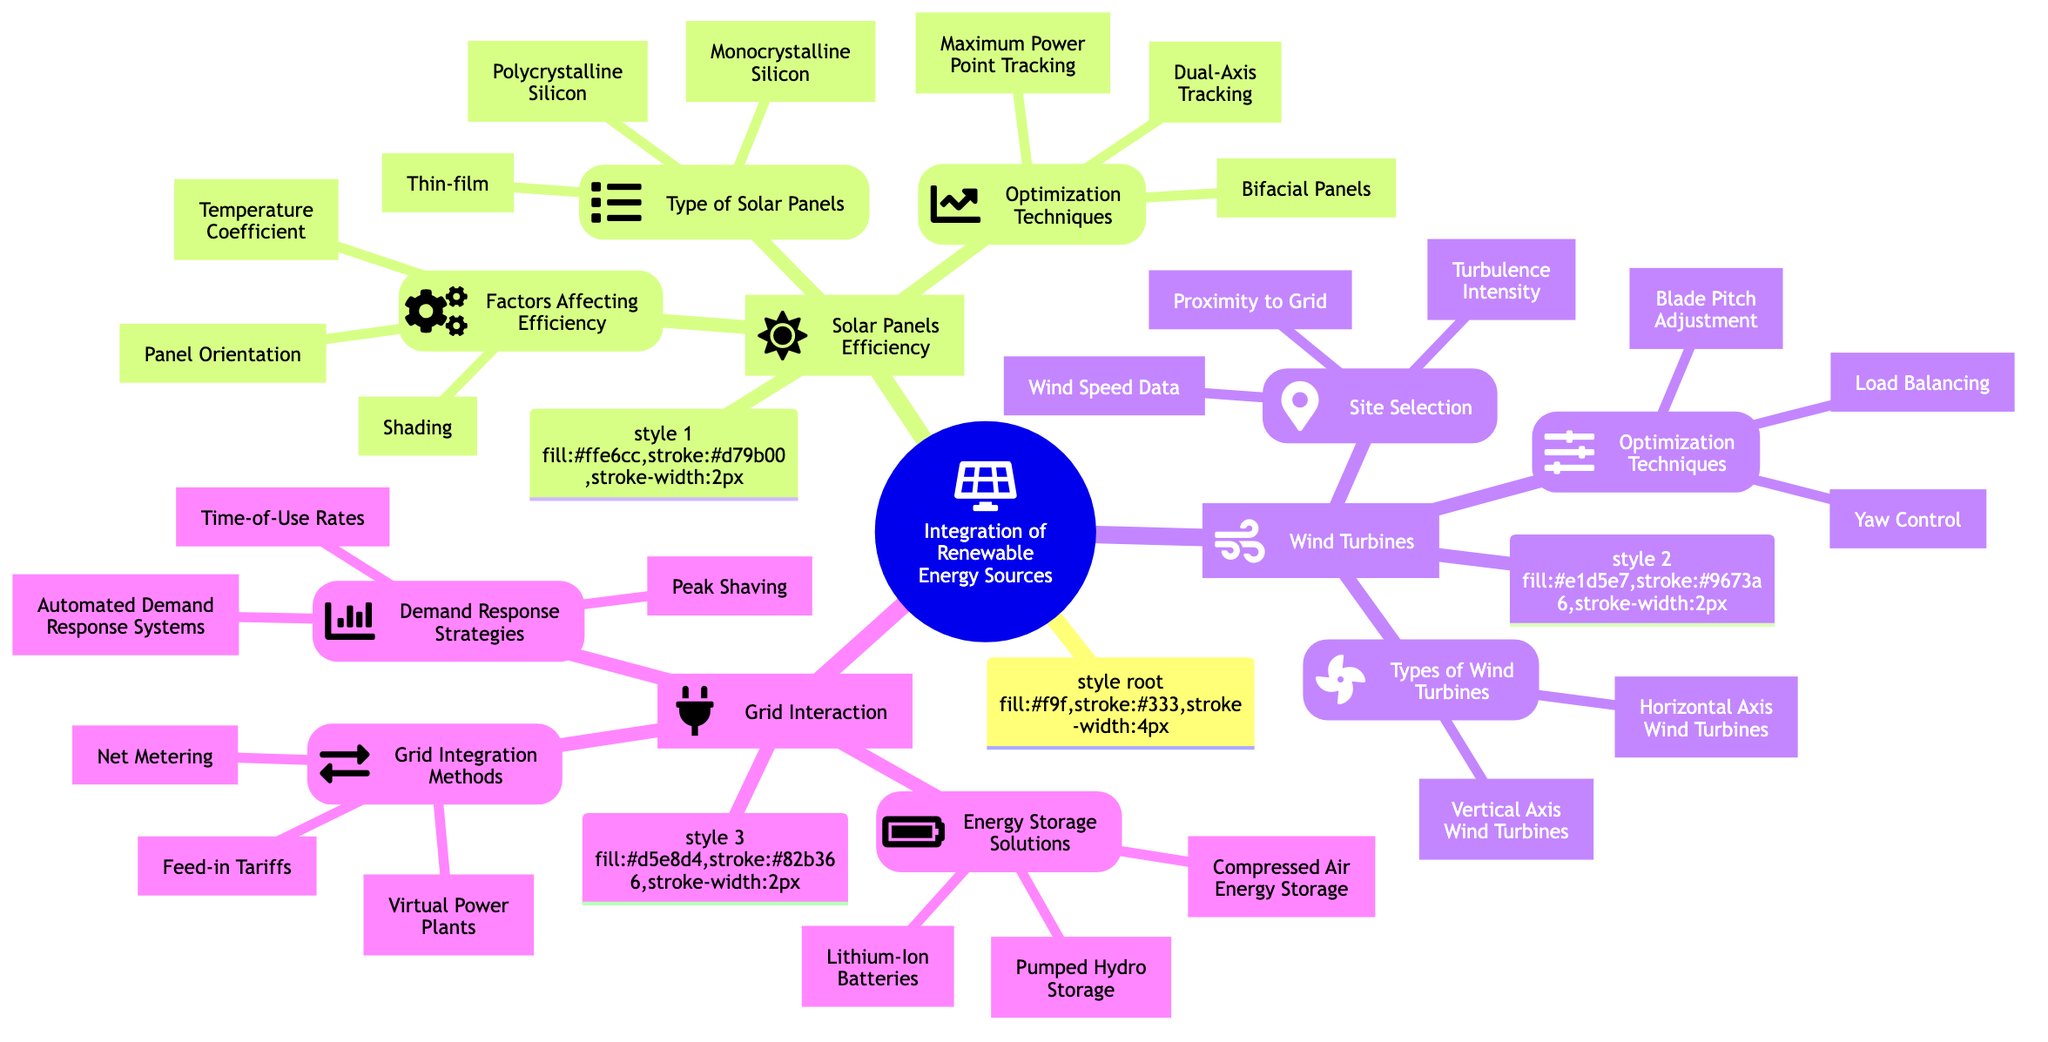What are the three types of solar panels? In the node "Type of Solar Panels" under "Solar Panels Efficiency," the diagram lists three types: Monocrystalline Silicon, Polycrystalline Silicon, and Thin-film. These are all detailed in the sub-nodes.
Answer: Monocrystalline Silicon, Polycrystalline Silicon, Thin-film What factors affect solar panel efficiency? The node "Factors Affecting Efficiency" outlines three specific factors: Temperature Coefficient, Panel Orientation, and Shading. These factors can hinder the performance of solar panels.
Answer: Temperature Coefficient, Panel Orientation, Shading How many optimization techniques are listed for wind turbines? In the "Optimization Techniques" node under "Wind Turbines," there are three listed techniques: Yaw Control, Blade Pitch Adjustment, and Load Balancing. Thus, the total count of techniques is three.
Answer: 3 What is one method for grid integration? The "Grid Integration Methods" node presents three specific strategies, of which one can be chosen to answer this question. These methods include Net Metering, Feed-in Tariffs, and Virtual Power Plants.
Answer: Net Metering Which energy storage solution is mentioned in the diagram? Under the "Energy Storage Solutions" node in the "Grid Interaction" section, three solutions are presented. One of the options is Lithium-Ion Batteries, which can serve as a direct answer here.
Answer: Lithium-Ion Batteries How many types of wind turbines are described? The node "Types of Wind Turbines" under "Wind Turbines" indicates two types: Horizontal Axis Wind Turbines and Vertical Axis Wind Turbines. Therefore, the count of types is two.
Answer: 2 What is the relationship between solar panel optimization techniques and their efficiency? The "Optimization Techniques" node outlines techniques like Maximum Power Point Tracking, Dual-Axis Tracking, and Bifacial Panels, all of which directly aim to enhance solar panel efficiency as described in the main section of the mind map.
Answer: Enhances efficiency What are two demand response strategies? In the "Demand Response Strategies" node, the diagram lists three strategies: Time-of-Use Rates, Automated Demand Response Systems, and Peak Shaving. Two can be selected from this list for the answer.
Answer: Time-of-Use Rates, Automated Demand Response Systems What are two types of wind turbines? From the "Types of Wind Turbines" node, two types can be highlighted: Horizontal Axis Wind Turbines and Vertical Axis Wind Turbines. Selecting any two will fulfill the requirement of this question.
Answer: Horizontal Axis Wind Turbines, Vertical Axis Wind Turbines 